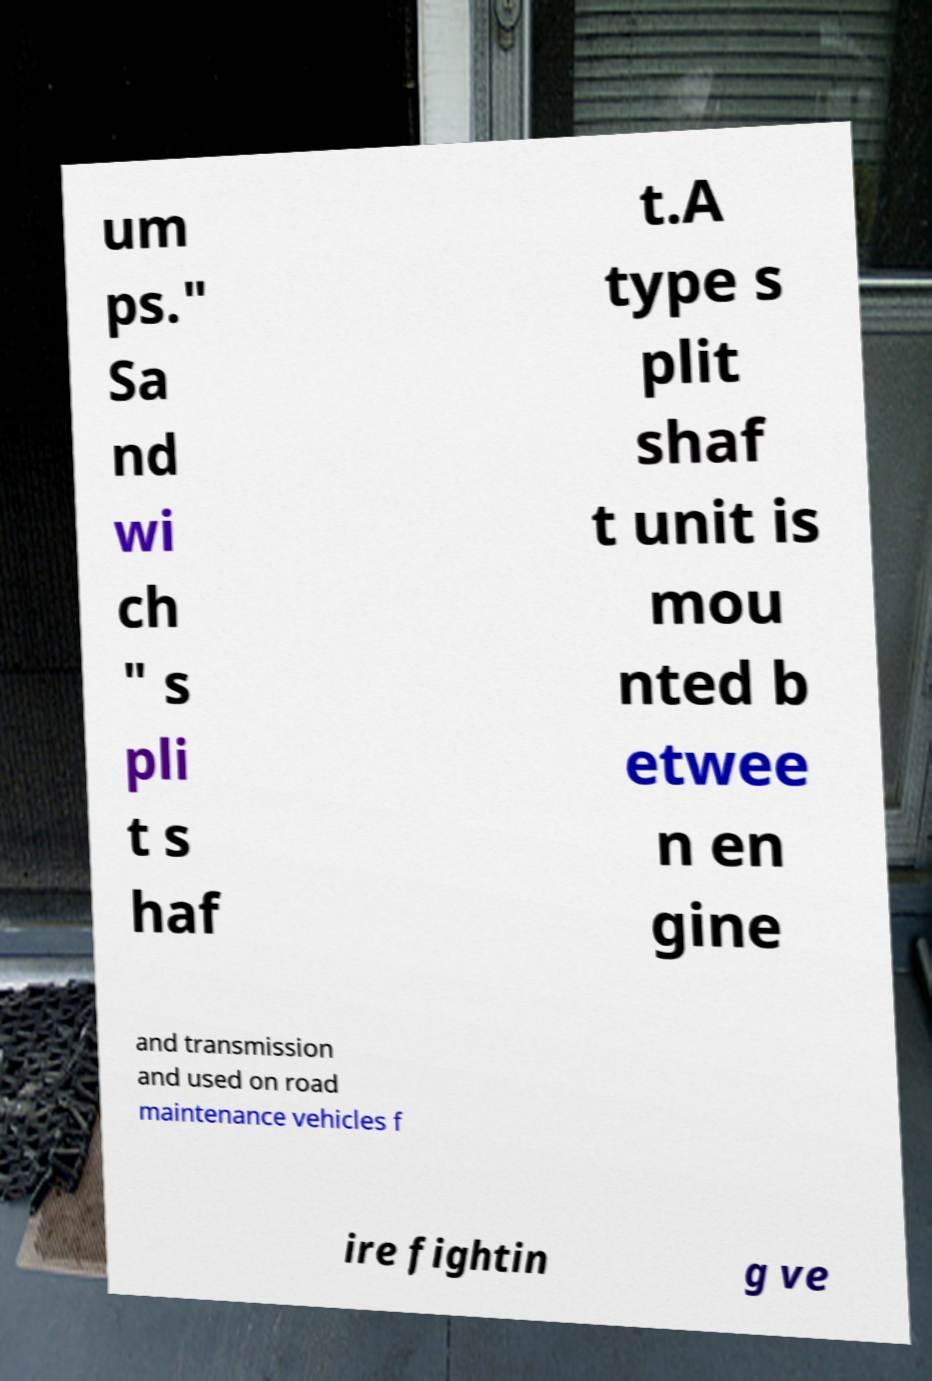For documentation purposes, I need the text within this image transcribed. Could you provide that? um ps." Sa nd wi ch " s pli t s haf t.A type s plit shaf t unit is mou nted b etwee n en gine and transmission and used on road maintenance vehicles f ire fightin g ve 